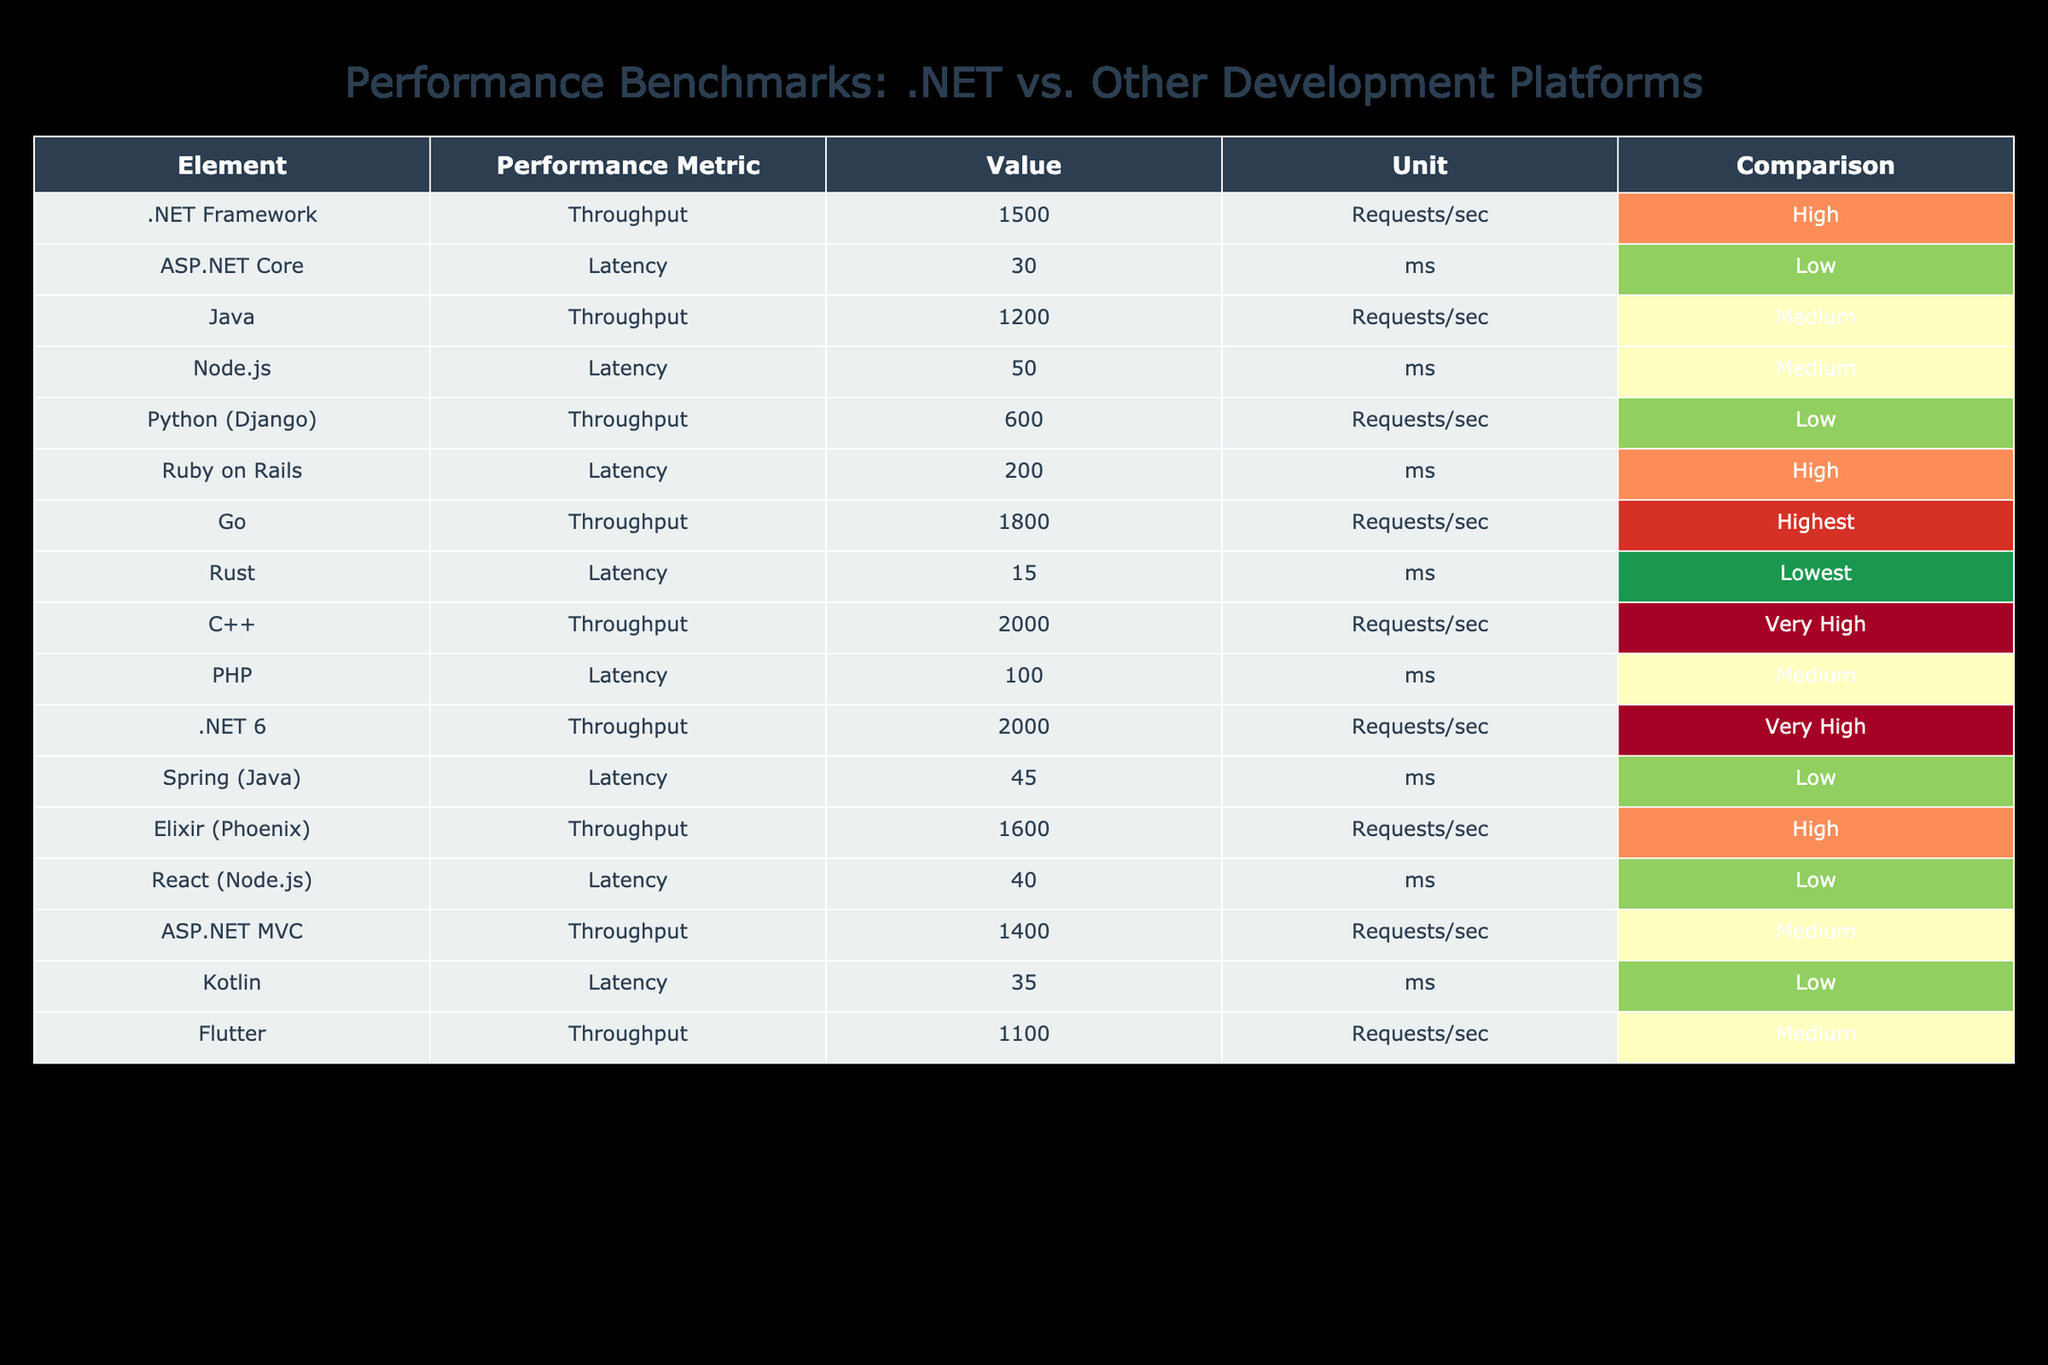What is the throughput of .NET 6? The table lists the throughput value for .NET 6 under the "Value" column. It shows a throughput of 2000 requests per second.
Answer: 2000 requests/sec Which platform has the lowest latency? By reviewing the "Latency" column, we can see that Rust has a latency of 15 ms, which is the lowest among all platforms listed.
Answer: Rust What is the average throughput of all listed platforms? To find the average throughput, we sum up the throughput values: (1500 + 1200 + 600 + 1800 + 2000 + 2000 + 1600 + 1400 + 1100 + 1800) = 14500 requests/sec. Then, we divide this sum by the number of platforms (10), which gives us an average of 1450 requests/sec.
Answer: 1450 requests/sec Is the latency of ASP.NET Core higher than that of Go? ASP.NET Core has a latency of 30 ms, while Go has a latency of 15 ms. Since 30 ms > 15 ms, the latency of ASP.NET Core is indeed higher than that of Go.
Answer: Yes How many platforms have a throughput greater than 1500 requests/sec? By examining the "Throughput" values, we find that .NET 6, C++, Go, and Elixir (Phoenix) all have throughputs greater than 1500 requests/sec. This makes a total of 4 platforms.
Answer: 4 platforms Which platform has high latency but still offers medium throughput? From the table, we observe that PHP has high latency (100 ms) while maintaining a medium throughput (600 requests/sec).
Answer: PHP Is the throughput of ASP.NET MVC less than that of Java? ASP.NET MVC has a throughput of 1400 requests/sec, whereas Java has a throughput of 1200 requests/sec. Since 1400 > 1200, the statement is false.
Answer: No What is the difference in latency between Python (Django) and Ruby on Rails? Python (Django) has a latency of 200 ms and Ruby on Rails has a latency of 200 ms as well. The difference in latency is 200 - 200 = 0 ms.
Answer: 0 ms How many platforms have a latency classified as low? By counting from the table, we find that 5 platforms are categorized as having low latency: ASP.NET Core, Node.js, Spring (Java), Kotlin, and React (Node.js).
Answer: 5 platforms 